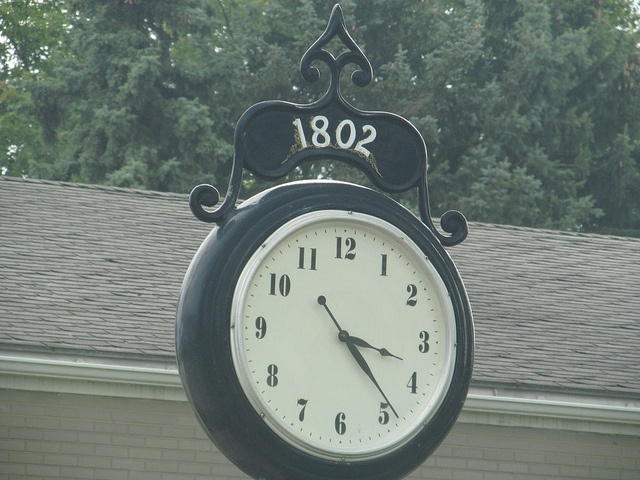Describe the objects in this image and their specific colors. I can see a clock in teal, purple, gray, lightgray, and darkgray tones in this image. 